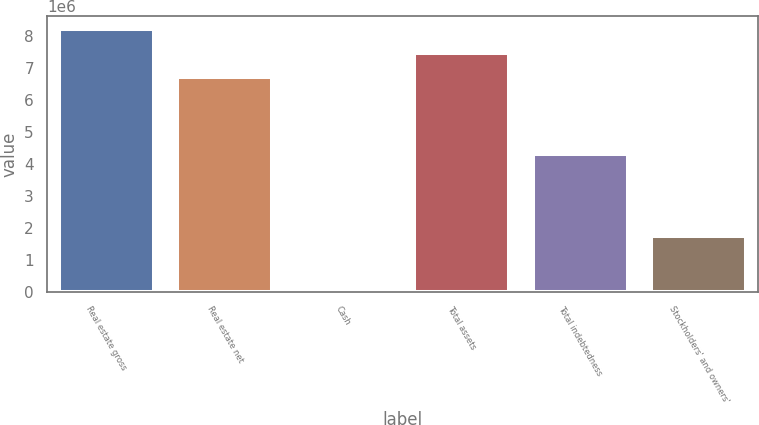Convert chart to OTSL. <chart><loc_0><loc_0><loc_500><loc_500><bar_chart><fcel>Real estate gross<fcel>Real estate net<fcel>Cash<fcel>Total assets<fcel>Total indebtedness<fcel>Stockholders' and owners'<nl><fcel>8.21002e+06<fcel>6.73805e+06<fcel>98067<fcel>7.47404e+06<fcel>4.31494e+06<fcel>1.75407e+06<nl></chart> 